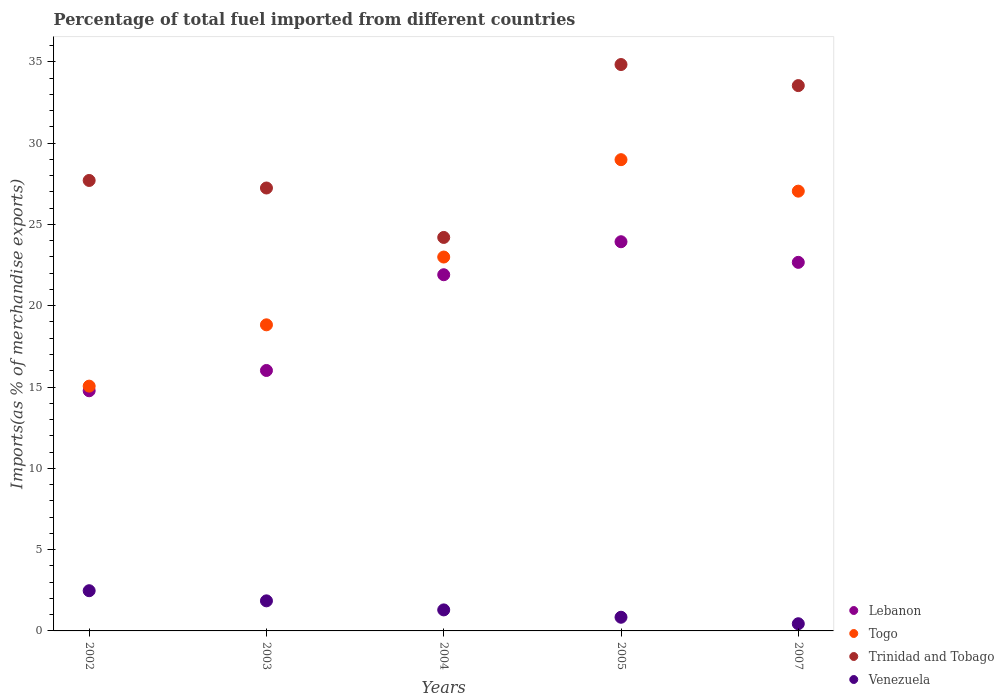Is the number of dotlines equal to the number of legend labels?
Offer a very short reply. Yes. What is the percentage of imports to different countries in Trinidad and Tobago in 2002?
Ensure brevity in your answer.  27.7. Across all years, what is the maximum percentage of imports to different countries in Togo?
Keep it short and to the point. 28.98. Across all years, what is the minimum percentage of imports to different countries in Togo?
Your answer should be very brief. 15.05. What is the total percentage of imports to different countries in Lebanon in the graph?
Offer a terse response. 99.29. What is the difference between the percentage of imports to different countries in Lebanon in 2002 and that in 2005?
Offer a very short reply. -9.16. What is the difference between the percentage of imports to different countries in Lebanon in 2005 and the percentage of imports to different countries in Venezuela in 2007?
Give a very brief answer. 23.49. What is the average percentage of imports to different countries in Lebanon per year?
Your answer should be very brief. 19.86. In the year 2005, what is the difference between the percentage of imports to different countries in Venezuela and percentage of imports to different countries in Togo?
Offer a very short reply. -28.14. What is the ratio of the percentage of imports to different countries in Venezuela in 2004 to that in 2005?
Keep it short and to the point. 1.54. Is the difference between the percentage of imports to different countries in Venezuela in 2002 and 2004 greater than the difference between the percentage of imports to different countries in Togo in 2002 and 2004?
Keep it short and to the point. Yes. What is the difference between the highest and the second highest percentage of imports to different countries in Venezuela?
Your response must be concise. 0.62. What is the difference between the highest and the lowest percentage of imports to different countries in Lebanon?
Provide a succinct answer. 9.16. Is it the case that in every year, the sum of the percentage of imports to different countries in Lebanon and percentage of imports to different countries in Togo  is greater than the sum of percentage of imports to different countries in Venezuela and percentage of imports to different countries in Trinidad and Tobago?
Provide a succinct answer. No. Is the percentage of imports to different countries in Lebanon strictly less than the percentage of imports to different countries in Trinidad and Tobago over the years?
Offer a terse response. Yes. How many dotlines are there?
Offer a very short reply. 4. How many years are there in the graph?
Your answer should be very brief. 5. Does the graph contain grids?
Offer a terse response. No. How many legend labels are there?
Ensure brevity in your answer.  4. What is the title of the graph?
Make the answer very short. Percentage of total fuel imported from different countries. Does "Israel" appear as one of the legend labels in the graph?
Make the answer very short. No. What is the label or title of the X-axis?
Keep it short and to the point. Years. What is the label or title of the Y-axis?
Your answer should be very brief. Imports(as % of merchandise exports). What is the Imports(as % of merchandise exports) of Lebanon in 2002?
Offer a very short reply. 14.77. What is the Imports(as % of merchandise exports) in Togo in 2002?
Provide a succinct answer. 15.05. What is the Imports(as % of merchandise exports) in Trinidad and Tobago in 2002?
Your response must be concise. 27.7. What is the Imports(as % of merchandise exports) of Venezuela in 2002?
Give a very brief answer. 2.47. What is the Imports(as % of merchandise exports) of Lebanon in 2003?
Offer a very short reply. 16.02. What is the Imports(as % of merchandise exports) of Togo in 2003?
Offer a terse response. 18.82. What is the Imports(as % of merchandise exports) in Trinidad and Tobago in 2003?
Offer a very short reply. 27.24. What is the Imports(as % of merchandise exports) in Venezuela in 2003?
Provide a succinct answer. 1.85. What is the Imports(as % of merchandise exports) in Lebanon in 2004?
Offer a terse response. 21.9. What is the Imports(as % of merchandise exports) of Togo in 2004?
Provide a short and direct response. 22.99. What is the Imports(as % of merchandise exports) in Trinidad and Tobago in 2004?
Give a very brief answer. 24.2. What is the Imports(as % of merchandise exports) of Venezuela in 2004?
Give a very brief answer. 1.29. What is the Imports(as % of merchandise exports) of Lebanon in 2005?
Provide a short and direct response. 23.93. What is the Imports(as % of merchandise exports) in Togo in 2005?
Your answer should be very brief. 28.98. What is the Imports(as % of merchandise exports) in Trinidad and Tobago in 2005?
Offer a very short reply. 34.83. What is the Imports(as % of merchandise exports) in Venezuela in 2005?
Your answer should be very brief. 0.84. What is the Imports(as % of merchandise exports) of Lebanon in 2007?
Provide a short and direct response. 22.67. What is the Imports(as % of merchandise exports) in Togo in 2007?
Your response must be concise. 27.04. What is the Imports(as % of merchandise exports) in Trinidad and Tobago in 2007?
Provide a succinct answer. 33.54. What is the Imports(as % of merchandise exports) in Venezuela in 2007?
Keep it short and to the point. 0.44. Across all years, what is the maximum Imports(as % of merchandise exports) in Lebanon?
Make the answer very short. 23.93. Across all years, what is the maximum Imports(as % of merchandise exports) of Togo?
Offer a very short reply. 28.98. Across all years, what is the maximum Imports(as % of merchandise exports) of Trinidad and Tobago?
Ensure brevity in your answer.  34.83. Across all years, what is the maximum Imports(as % of merchandise exports) of Venezuela?
Your response must be concise. 2.47. Across all years, what is the minimum Imports(as % of merchandise exports) in Lebanon?
Your response must be concise. 14.77. Across all years, what is the minimum Imports(as % of merchandise exports) in Togo?
Offer a very short reply. 15.05. Across all years, what is the minimum Imports(as % of merchandise exports) of Trinidad and Tobago?
Your answer should be very brief. 24.2. Across all years, what is the minimum Imports(as % of merchandise exports) of Venezuela?
Provide a succinct answer. 0.44. What is the total Imports(as % of merchandise exports) of Lebanon in the graph?
Keep it short and to the point. 99.29. What is the total Imports(as % of merchandise exports) of Togo in the graph?
Give a very brief answer. 112.9. What is the total Imports(as % of merchandise exports) of Trinidad and Tobago in the graph?
Offer a very short reply. 147.51. What is the total Imports(as % of merchandise exports) in Venezuela in the graph?
Offer a very short reply. 6.9. What is the difference between the Imports(as % of merchandise exports) in Lebanon in 2002 and that in 2003?
Provide a succinct answer. -1.25. What is the difference between the Imports(as % of merchandise exports) in Togo in 2002 and that in 2003?
Keep it short and to the point. -3.77. What is the difference between the Imports(as % of merchandise exports) in Trinidad and Tobago in 2002 and that in 2003?
Make the answer very short. 0.46. What is the difference between the Imports(as % of merchandise exports) in Venezuela in 2002 and that in 2003?
Make the answer very short. 0.62. What is the difference between the Imports(as % of merchandise exports) of Lebanon in 2002 and that in 2004?
Your response must be concise. -7.14. What is the difference between the Imports(as % of merchandise exports) in Togo in 2002 and that in 2004?
Your answer should be compact. -7.94. What is the difference between the Imports(as % of merchandise exports) of Trinidad and Tobago in 2002 and that in 2004?
Your answer should be compact. 3.5. What is the difference between the Imports(as % of merchandise exports) of Venezuela in 2002 and that in 2004?
Your answer should be compact. 1.18. What is the difference between the Imports(as % of merchandise exports) in Lebanon in 2002 and that in 2005?
Your answer should be compact. -9.16. What is the difference between the Imports(as % of merchandise exports) of Togo in 2002 and that in 2005?
Provide a succinct answer. -13.93. What is the difference between the Imports(as % of merchandise exports) of Trinidad and Tobago in 2002 and that in 2005?
Ensure brevity in your answer.  -7.13. What is the difference between the Imports(as % of merchandise exports) in Venezuela in 2002 and that in 2005?
Make the answer very short. 1.63. What is the difference between the Imports(as % of merchandise exports) in Lebanon in 2002 and that in 2007?
Make the answer very short. -7.9. What is the difference between the Imports(as % of merchandise exports) in Togo in 2002 and that in 2007?
Offer a very short reply. -11.99. What is the difference between the Imports(as % of merchandise exports) of Trinidad and Tobago in 2002 and that in 2007?
Keep it short and to the point. -5.83. What is the difference between the Imports(as % of merchandise exports) in Venezuela in 2002 and that in 2007?
Offer a very short reply. 2.03. What is the difference between the Imports(as % of merchandise exports) of Lebanon in 2003 and that in 2004?
Offer a very short reply. -5.89. What is the difference between the Imports(as % of merchandise exports) of Togo in 2003 and that in 2004?
Offer a very short reply. -4.17. What is the difference between the Imports(as % of merchandise exports) in Trinidad and Tobago in 2003 and that in 2004?
Make the answer very short. 3.04. What is the difference between the Imports(as % of merchandise exports) in Venezuela in 2003 and that in 2004?
Your answer should be compact. 0.56. What is the difference between the Imports(as % of merchandise exports) of Lebanon in 2003 and that in 2005?
Ensure brevity in your answer.  -7.92. What is the difference between the Imports(as % of merchandise exports) in Togo in 2003 and that in 2005?
Provide a short and direct response. -10.16. What is the difference between the Imports(as % of merchandise exports) of Trinidad and Tobago in 2003 and that in 2005?
Offer a terse response. -7.59. What is the difference between the Imports(as % of merchandise exports) in Venezuela in 2003 and that in 2005?
Give a very brief answer. 1.01. What is the difference between the Imports(as % of merchandise exports) in Lebanon in 2003 and that in 2007?
Make the answer very short. -6.65. What is the difference between the Imports(as % of merchandise exports) of Togo in 2003 and that in 2007?
Your answer should be compact. -8.22. What is the difference between the Imports(as % of merchandise exports) in Trinidad and Tobago in 2003 and that in 2007?
Ensure brevity in your answer.  -6.3. What is the difference between the Imports(as % of merchandise exports) of Venezuela in 2003 and that in 2007?
Your answer should be very brief. 1.41. What is the difference between the Imports(as % of merchandise exports) in Lebanon in 2004 and that in 2005?
Your answer should be compact. -2.03. What is the difference between the Imports(as % of merchandise exports) of Togo in 2004 and that in 2005?
Your answer should be compact. -5.99. What is the difference between the Imports(as % of merchandise exports) in Trinidad and Tobago in 2004 and that in 2005?
Offer a terse response. -10.63. What is the difference between the Imports(as % of merchandise exports) in Venezuela in 2004 and that in 2005?
Give a very brief answer. 0.45. What is the difference between the Imports(as % of merchandise exports) of Lebanon in 2004 and that in 2007?
Your response must be concise. -0.76. What is the difference between the Imports(as % of merchandise exports) in Togo in 2004 and that in 2007?
Give a very brief answer. -4.05. What is the difference between the Imports(as % of merchandise exports) in Trinidad and Tobago in 2004 and that in 2007?
Provide a succinct answer. -9.34. What is the difference between the Imports(as % of merchandise exports) in Venezuela in 2004 and that in 2007?
Your answer should be compact. 0.85. What is the difference between the Imports(as % of merchandise exports) in Lebanon in 2005 and that in 2007?
Offer a very short reply. 1.27. What is the difference between the Imports(as % of merchandise exports) in Togo in 2005 and that in 2007?
Give a very brief answer. 1.94. What is the difference between the Imports(as % of merchandise exports) of Trinidad and Tobago in 2005 and that in 2007?
Your answer should be compact. 1.3. What is the difference between the Imports(as % of merchandise exports) of Venezuela in 2005 and that in 2007?
Ensure brevity in your answer.  0.4. What is the difference between the Imports(as % of merchandise exports) in Lebanon in 2002 and the Imports(as % of merchandise exports) in Togo in 2003?
Provide a short and direct response. -4.06. What is the difference between the Imports(as % of merchandise exports) in Lebanon in 2002 and the Imports(as % of merchandise exports) in Trinidad and Tobago in 2003?
Offer a terse response. -12.47. What is the difference between the Imports(as % of merchandise exports) in Lebanon in 2002 and the Imports(as % of merchandise exports) in Venezuela in 2003?
Offer a terse response. 12.92. What is the difference between the Imports(as % of merchandise exports) of Togo in 2002 and the Imports(as % of merchandise exports) of Trinidad and Tobago in 2003?
Give a very brief answer. -12.18. What is the difference between the Imports(as % of merchandise exports) of Togo in 2002 and the Imports(as % of merchandise exports) of Venezuela in 2003?
Make the answer very short. 13.2. What is the difference between the Imports(as % of merchandise exports) of Trinidad and Tobago in 2002 and the Imports(as % of merchandise exports) of Venezuela in 2003?
Keep it short and to the point. 25.85. What is the difference between the Imports(as % of merchandise exports) of Lebanon in 2002 and the Imports(as % of merchandise exports) of Togo in 2004?
Give a very brief answer. -8.22. What is the difference between the Imports(as % of merchandise exports) in Lebanon in 2002 and the Imports(as % of merchandise exports) in Trinidad and Tobago in 2004?
Your response must be concise. -9.43. What is the difference between the Imports(as % of merchandise exports) of Lebanon in 2002 and the Imports(as % of merchandise exports) of Venezuela in 2004?
Offer a very short reply. 13.48. What is the difference between the Imports(as % of merchandise exports) in Togo in 2002 and the Imports(as % of merchandise exports) in Trinidad and Tobago in 2004?
Make the answer very short. -9.14. What is the difference between the Imports(as % of merchandise exports) of Togo in 2002 and the Imports(as % of merchandise exports) of Venezuela in 2004?
Your answer should be very brief. 13.76. What is the difference between the Imports(as % of merchandise exports) in Trinidad and Tobago in 2002 and the Imports(as % of merchandise exports) in Venezuela in 2004?
Ensure brevity in your answer.  26.41. What is the difference between the Imports(as % of merchandise exports) in Lebanon in 2002 and the Imports(as % of merchandise exports) in Togo in 2005?
Give a very brief answer. -14.21. What is the difference between the Imports(as % of merchandise exports) of Lebanon in 2002 and the Imports(as % of merchandise exports) of Trinidad and Tobago in 2005?
Offer a very short reply. -20.06. What is the difference between the Imports(as % of merchandise exports) of Lebanon in 2002 and the Imports(as % of merchandise exports) of Venezuela in 2005?
Provide a short and direct response. 13.93. What is the difference between the Imports(as % of merchandise exports) in Togo in 2002 and the Imports(as % of merchandise exports) in Trinidad and Tobago in 2005?
Your answer should be compact. -19.78. What is the difference between the Imports(as % of merchandise exports) in Togo in 2002 and the Imports(as % of merchandise exports) in Venezuela in 2005?
Your response must be concise. 14.21. What is the difference between the Imports(as % of merchandise exports) in Trinidad and Tobago in 2002 and the Imports(as % of merchandise exports) in Venezuela in 2005?
Your answer should be very brief. 26.86. What is the difference between the Imports(as % of merchandise exports) in Lebanon in 2002 and the Imports(as % of merchandise exports) in Togo in 2007?
Offer a terse response. -12.28. What is the difference between the Imports(as % of merchandise exports) in Lebanon in 2002 and the Imports(as % of merchandise exports) in Trinidad and Tobago in 2007?
Make the answer very short. -18.77. What is the difference between the Imports(as % of merchandise exports) of Lebanon in 2002 and the Imports(as % of merchandise exports) of Venezuela in 2007?
Offer a terse response. 14.33. What is the difference between the Imports(as % of merchandise exports) of Togo in 2002 and the Imports(as % of merchandise exports) of Trinidad and Tobago in 2007?
Offer a terse response. -18.48. What is the difference between the Imports(as % of merchandise exports) of Togo in 2002 and the Imports(as % of merchandise exports) of Venezuela in 2007?
Your response must be concise. 14.61. What is the difference between the Imports(as % of merchandise exports) of Trinidad and Tobago in 2002 and the Imports(as % of merchandise exports) of Venezuela in 2007?
Offer a very short reply. 27.26. What is the difference between the Imports(as % of merchandise exports) of Lebanon in 2003 and the Imports(as % of merchandise exports) of Togo in 2004?
Provide a succinct answer. -6.98. What is the difference between the Imports(as % of merchandise exports) of Lebanon in 2003 and the Imports(as % of merchandise exports) of Trinidad and Tobago in 2004?
Provide a short and direct response. -8.18. What is the difference between the Imports(as % of merchandise exports) of Lebanon in 2003 and the Imports(as % of merchandise exports) of Venezuela in 2004?
Make the answer very short. 14.72. What is the difference between the Imports(as % of merchandise exports) in Togo in 2003 and the Imports(as % of merchandise exports) in Trinidad and Tobago in 2004?
Offer a very short reply. -5.37. What is the difference between the Imports(as % of merchandise exports) of Togo in 2003 and the Imports(as % of merchandise exports) of Venezuela in 2004?
Keep it short and to the point. 17.53. What is the difference between the Imports(as % of merchandise exports) of Trinidad and Tobago in 2003 and the Imports(as % of merchandise exports) of Venezuela in 2004?
Give a very brief answer. 25.95. What is the difference between the Imports(as % of merchandise exports) in Lebanon in 2003 and the Imports(as % of merchandise exports) in Togo in 2005?
Your answer should be compact. -12.96. What is the difference between the Imports(as % of merchandise exports) of Lebanon in 2003 and the Imports(as % of merchandise exports) of Trinidad and Tobago in 2005?
Your response must be concise. -18.81. What is the difference between the Imports(as % of merchandise exports) of Lebanon in 2003 and the Imports(as % of merchandise exports) of Venezuela in 2005?
Offer a terse response. 15.18. What is the difference between the Imports(as % of merchandise exports) of Togo in 2003 and the Imports(as % of merchandise exports) of Trinidad and Tobago in 2005?
Offer a terse response. -16.01. What is the difference between the Imports(as % of merchandise exports) of Togo in 2003 and the Imports(as % of merchandise exports) of Venezuela in 2005?
Keep it short and to the point. 17.98. What is the difference between the Imports(as % of merchandise exports) of Trinidad and Tobago in 2003 and the Imports(as % of merchandise exports) of Venezuela in 2005?
Keep it short and to the point. 26.4. What is the difference between the Imports(as % of merchandise exports) in Lebanon in 2003 and the Imports(as % of merchandise exports) in Togo in 2007?
Ensure brevity in your answer.  -11.03. What is the difference between the Imports(as % of merchandise exports) of Lebanon in 2003 and the Imports(as % of merchandise exports) of Trinidad and Tobago in 2007?
Offer a terse response. -17.52. What is the difference between the Imports(as % of merchandise exports) of Lebanon in 2003 and the Imports(as % of merchandise exports) of Venezuela in 2007?
Make the answer very short. 15.57. What is the difference between the Imports(as % of merchandise exports) in Togo in 2003 and the Imports(as % of merchandise exports) in Trinidad and Tobago in 2007?
Offer a terse response. -14.71. What is the difference between the Imports(as % of merchandise exports) of Togo in 2003 and the Imports(as % of merchandise exports) of Venezuela in 2007?
Offer a very short reply. 18.38. What is the difference between the Imports(as % of merchandise exports) of Trinidad and Tobago in 2003 and the Imports(as % of merchandise exports) of Venezuela in 2007?
Offer a terse response. 26.8. What is the difference between the Imports(as % of merchandise exports) of Lebanon in 2004 and the Imports(as % of merchandise exports) of Togo in 2005?
Give a very brief answer. -7.08. What is the difference between the Imports(as % of merchandise exports) of Lebanon in 2004 and the Imports(as % of merchandise exports) of Trinidad and Tobago in 2005?
Make the answer very short. -12.93. What is the difference between the Imports(as % of merchandise exports) of Lebanon in 2004 and the Imports(as % of merchandise exports) of Venezuela in 2005?
Give a very brief answer. 21.06. What is the difference between the Imports(as % of merchandise exports) in Togo in 2004 and the Imports(as % of merchandise exports) in Trinidad and Tobago in 2005?
Give a very brief answer. -11.84. What is the difference between the Imports(as % of merchandise exports) in Togo in 2004 and the Imports(as % of merchandise exports) in Venezuela in 2005?
Provide a succinct answer. 22.15. What is the difference between the Imports(as % of merchandise exports) in Trinidad and Tobago in 2004 and the Imports(as % of merchandise exports) in Venezuela in 2005?
Your response must be concise. 23.36. What is the difference between the Imports(as % of merchandise exports) in Lebanon in 2004 and the Imports(as % of merchandise exports) in Togo in 2007?
Offer a terse response. -5.14. What is the difference between the Imports(as % of merchandise exports) of Lebanon in 2004 and the Imports(as % of merchandise exports) of Trinidad and Tobago in 2007?
Your answer should be compact. -11.63. What is the difference between the Imports(as % of merchandise exports) of Lebanon in 2004 and the Imports(as % of merchandise exports) of Venezuela in 2007?
Provide a short and direct response. 21.46. What is the difference between the Imports(as % of merchandise exports) of Togo in 2004 and the Imports(as % of merchandise exports) of Trinidad and Tobago in 2007?
Your answer should be compact. -10.54. What is the difference between the Imports(as % of merchandise exports) in Togo in 2004 and the Imports(as % of merchandise exports) in Venezuela in 2007?
Ensure brevity in your answer.  22.55. What is the difference between the Imports(as % of merchandise exports) in Trinidad and Tobago in 2004 and the Imports(as % of merchandise exports) in Venezuela in 2007?
Offer a terse response. 23.76. What is the difference between the Imports(as % of merchandise exports) in Lebanon in 2005 and the Imports(as % of merchandise exports) in Togo in 2007?
Offer a very short reply. -3.11. What is the difference between the Imports(as % of merchandise exports) in Lebanon in 2005 and the Imports(as % of merchandise exports) in Trinidad and Tobago in 2007?
Your answer should be compact. -9.6. What is the difference between the Imports(as % of merchandise exports) in Lebanon in 2005 and the Imports(as % of merchandise exports) in Venezuela in 2007?
Your response must be concise. 23.49. What is the difference between the Imports(as % of merchandise exports) in Togo in 2005 and the Imports(as % of merchandise exports) in Trinidad and Tobago in 2007?
Make the answer very short. -4.56. What is the difference between the Imports(as % of merchandise exports) in Togo in 2005 and the Imports(as % of merchandise exports) in Venezuela in 2007?
Provide a short and direct response. 28.54. What is the difference between the Imports(as % of merchandise exports) in Trinidad and Tobago in 2005 and the Imports(as % of merchandise exports) in Venezuela in 2007?
Keep it short and to the point. 34.39. What is the average Imports(as % of merchandise exports) in Lebanon per year?
Your answer should be compact. 19.86. What is the average Imports(as % of merchandise exports) of Togo per year?
Your response must be concise. 22.58. What is the average Imports(as % of merchandise exports) in Trinidad and Tobago per year?
Make the answer very short. 29.5. What is the average Imports(as % of merchandise exports) of Venezuela per year?
Your response must be concise. 1.38. In the year 2002, what is the difference between the Imports(as % of merchandise exports) in Lebanon and Imports(as % of merchandise exports) in Togo?
Your answer should be very brief. -0.28. In the year 2002, what is the difference between the Imports(as % of merchandise exports) of Lebanon and Imports(as % of merchandise exports) of Trinidad and Tobago?
Provide a short and direct response. -12.93. In the year 2002, what is the difference between the Imports(as % of merchandise exports) of Lebanon and Imports(as % of merchandise exports) of Venezuela?
Give a very brief answer. 12.3. In the year 2002, what is the difference between the Imports(as % of merchandise exports) of Togo and Imports(as % of merchandise exports) of Trinidad and Tobago?
Offer a very short reply. -12.65. In the year 2002, what is the difference between the Imports(as % of merchandise exports) of Togo and Imports(as % of merchandise exports) of Venezuela?
Offer a very short reply. 12.58. In the year 2002, what is the difference between the Imports(as % of merchandise exports) of Trinidad and Tobago and Imports(as % of merchandise exports) of Venezuela?
Your response must be concise. 25.23. In the year 2003, what is the difference between the Imports(as % of merchandise exports) of Lebanon and Imports(as % of merchandise exports) of Togo?
Your answer should be very brief. -2.81. In the year 2003, what is the difference between the Imports(as % of merchandise exports) of Lebanon and Imports(as % of merchandise exports) of Trinidad and Tobago?
Keep it short and to the point. -11.22. In the year 2003, what is the difference between the Imports(as % of merchandise exports) of Lebanon and Imports(as % of merchandise exports) of Venezuela?
Your answer should be very brief. 14.17. In the year 2003, what is the difference between the Imports(as % of merchandise exports) of Togo and Imports(as % of merchandise exports) of Trinidad and Tobago?
Offer a terse response. -8.41. In the year 2003, what is the difference between the Imports(as % of merchandise exports) of Togo and Imports(as % of merchandise exports) of Venezuela?
Ensure brevity in your answer.  16.97. In the year 2003, what is the difference between the Imports(as % of merchandise exports) in Trinidad and Tobago and Imports(as % of merchandise exports) in Venezuela?
Make the answer very short. 25.39. In the year 2004, what is the difference between the Imports(as % of merchandise exports) in Lebanon and Imports(as % of merchandise exports) in Togo?
Give a very brief answer. -1.09. In the year 2004, what is the difference between the Imports(as % of merchandise exports) in Lebanon and Imports(as % of merchandise exports) in Trinidad and Tobago?
Offer a very short reply. -2.29. In the year 2004, what is the difference between the Imports(as % of merchandise exports) of Lebanon and Imports(as % of merchandise exports) of Venezuela?
Your answer should be very brief. 20.61. In the year 2004, what is the difference between the Imports(as % of merchandise exports) in Togo and Imports(as % of merchandise exports) in Trinidad and Tobago?
Provide a short and direct response. -1.21. In the year 2004, what is the difference between the Imports(as % of merchandise exports) in Togo and Imports(as % of merchandise exports) in Venezuela?
Keep it short and to the point. 21.7. In the year 2004, what is the difference between the Imports(as % of merchandise exports) of Trinidad and Tobago and Imports(as % of merchandise exports) of Venezuela?
Keep it short and to the point. 22.91. In the year 2005, what is the difference between the Imports(as % of merchandise exports) in Lebanon and Imports(as % of merchandise exports) in Togo?
Make the answer very short. -5.05. In the year 2005, what is the difference between the Imports(as % of merchandise exports) in Lebanon and Imports(as % of merchandise exports) in Trinidad and Tobago?
Your answer should be very brief. -10.9. In the year 2005, what is the difference between the Imports(as % of merchandise exports) in Lebanon and Imports(as % of merchandise exports) in Venezuela?
Your answer should be compact. 23.09. In the year 2005, what is the difference between the Imports(as % of merchandise exports) of Togo and Imports(as % of merchandise exports) of Trinidad and Tobago?
Keep it short and to the point. -5.85. In the year 2005, what is the difference between the Imports(as % of merchandise exports) of Togo and Imports(as % of merchandise exports) of Venezuela?
Provide a succinct answer. 28.14. In the year 2005, what is the difference between the Imports(as % of merchandise exports) of Trinidad and Tobago and Imports(as % of merchandise exports) of Venezuela?
Offer a very short reply. 33.99. In the year 2007, what is the difference between the Imports(as % of merchandise exports) in Lebanon and Imports(as % of merchandise exports) in Togo?
Give a very brief answer. -4.38. In the year 2007, what is the difference between the Imports(as % of merchandise exports) of Lebanon and Imports(as % of merchandise exports) of Trinidad and Tobago?
Offer a terse response. -10.87. In the year 2007, what is the difference between the Imports(as % of merchandise exports) in Lebanon and Imports(as % of merchandise exports) in Venezuela?
Provide a succinct answer. 22.22. In the year 2007, what is the difference between the Imports(as % of merchandise exports) of Togo and Imports(as % of merchandise exports) of Trinidad and Tobago?
Keep it short and to the point. -6.49. In the year 2007, what is the difference between the Imports(as % of merchandise exports) in Togo and Imports(as % of merchandise exports) in Venezuela?
Keep it short and to the point. 26.6. In the year 2007, what is the difference between the Imports(as % of merchandise exports) in Trinidad and Tobago and Imports(as % of merchandise exports) in Venezuela?
Your answer should be very brief. 33.09. What is the ratio of the Imports(as % of merchandise exports) in Lebanon in 2002 to that in 2003?
Your response must be concise. 0.92. What is the ratio of the Imports(as % of merchandise exports) of Togo in 2002 to that in 2003?
Offer a terse response. 0.8. What is the ratio of the Imports(as % of merchandise exports) in Trinidad and Tobago in 2002 to that in 2003?
Offer a very short reply. 1.02. What is the ratio of the Imports(as % of merchandise exports) of Venezuela in 2002 to that in 2003?
Your answer should be compact. 1.34. What is the ratio of the Imports(as % of merchandise exports) in Lebanon in 2002 to that in 2004?
Ensure brevity in your answer.  0.67. What is the ratio of the Imports(as % of merchandise exports) in Togo in 2002 to that in 2004?
Your answer should be compact. 0.65. What is the ratio of the Imports(as % of merchandise exports) of Trinidad and Tobago in 2002 to that in 2004?
Your answer should be compact. 1.14. What is the ratio of the Imports(as % of merchandise exports) of Venezuela in 2002 to that in 2004?
Provide a succinct answer. 1.91. What is the ratio of the Imports(as % of merchandise exports) of Lebanon in 2002 to that in 2005?
Provide a short and direct response. 0.62. What is the ratio of the Imports(as % of merchandise exports) in Togo in 2002 to that in 2005?
Provide a succinct answer. 0.52. What is the ratio of the Imports(as % of merchandise exports) in Trinidad and Tobago in 2002 to that in 2005?
Your answer should be very brief. 0.8. What is the ratio of the Imports(as % of merchandise exports) in Venezuela in 2002 to that in 2005?
Keep it short and to the point. 2.94. What is the ratio of the Imports(as % of merchandise exports) in Lebanon in 2002 to that in 2007?
Give a very brief answer. 0.65. What is the ratio of the Imports(as % of merchandise exports) in Togo in 2002 to that in 2007?
Give a very brief answer. 0.56. What is the ratio of the Imports(as % of merchandise exports) of Trinidad and Tobago in 2002 to that in 2007?
Keep it short and to the point. 0.83. What is the ratio of the Imports(as % of merchandise exports) in Venezuela in 2002 to that in 2007?
Provide a short and direct response. 5.59. What is the ratio of the Imports(as % of merchandise exports) of Lebanon in 2003 to that in 2004?
Give a very brief answer. 0.73. What is the ratio of the Imports(as % of merchandise exports) of Togo in 2003 to that in 2004?
Offer a terse response. 0.82. What is the ratio of the Imports(as % of merchandise exports) in Trinidad and Tobago in 2003 to that in 2004?
Ensure brevity in your answer.  1.13. What is the ratio of the Imports(as % of merchandise exports) in Venezuela in 2003 to that in 2004?
Your answer should be very brief. 1.43. What is the ratio of the Imports(as % of merchandise exports) in Lebanon in 2003 to that in 2005?
Your response must be concise. 0.67. What is the ratio of the Imports(as % of merchandise exports) of Togo in 2003 to that in 2005?
Give a very brief answer. 0.65. What is the ratio of the Imports(as % of merchandise exports) of Trinidad and Tobago in 2003 to that in 2005?
Your answer should be compact. 0.78. What is the ratio of the Imports(as % of merchandise exports) of Venezuela in 2003 to that in 2005?
Offer a very short reply. 2.2. What is the ratio of the Imports(as % of merchandise exports) in Lebanon in 2003 to that in 2007?
Offer a very short reply. 0.71. What is the ratio of the Imports(as % of merchandise exports) of Togo in 2003 to that in 2007?
Provide a succinct answer. 0.7. What is the ratio of the Imports(as % of merchandise exports) of Trinidad and Tobago in 2003 to that in 2007?
Make the answer very short. 0.81. What is the ratio of the Imports(as % of merchandise exports) in Venezuela in 2003 to that in 2007?
Your answer should be very brief. 4.18. What is the ratio of the Imports(as % of merchandise exports) in Lebanon in 2004 to that in 2005?
Provide a short and direct response. 0.92. What is the ratio of the Imports(as % of merchandise exports) in Togo in 2004 to that in 2005?
Make the answer very short. 0.79. What is the ratio of the Imports(as % of merchandise exports) of Trinidad and Tobago in 2004 to that in 2005?
Ensure brevity in your answer.  0.69. What is the ratio of the Imports(as % of merchandise exports) in Venezuela in 2004 to that in 2005?
Make the answer very short. 1.54. What is the ratio of the Imports(as % of merchandise exports) in Lebanon in 2004 to that in 2007?
Offer a terse response. 0.97. What is the ratio of the Imports(as % of merchandise exports) of Togo in 2004 to that in 2007?
Give a very brief answer. 0.85. What is the ratio of the Imports(as % of merchandise exports) of Trinidad and Tobago in 2004 to that in 2007?
Offer a terse response. 0.72. What is the ratio of the Imports(as % of merchandise exports) in Venezuela in 2004 to that in 2007?
Ensure brevity in your answer.  2.92. What is the ratio of the Imports(as % of merchandise exports) of Lebanon in 2005 to that in 2007?
Give a very brief answer. 1.06. What is the ratio of the Imports(as % of merchandise exports) in Togo in 2005 to that in 2007?
Provide a short and direct response. 1.07. What is the ratio of the Imports(as % of merchandise exports) of Trinidad and Tobago in 2005 to that in 2007?
Offer a terse response. 1.04. What is the ratio of the Imports(as % of merchandise exports) of Venezuela in 2005 to that in 2007?
Your response must be concise. 1.9. What is the difference between the highest and the second highest Imports(as % of merchandise exports) in Lebanon?
Offer a very short reply. 1.27. What is the difference between the highest and the second highest Imports(as % of merchandise exports) of Togo?
Your answer should be compact. 1.94. What is the difference between the highest and the second highest Imports(as % of merchandise exports) of Trinidad and Tobago?
Offer a very short reply. 1.3. What is the difference between the highest and the second highest Imports(as % of merchandise exports) in Venezuela?
Offer a terse response. 0.62. What is the difference between the highest and the lowest Imports(as % of merchandise exports) of Lebanon?
Provide a short and direct response. 9.16. What is the difference between the highest and the lowest Imports(as % of merchandise exports) in Togo?
Make the answer very short. 13.93. What is the difference between the highest and the lowest Imports(as % of merchandise exports) of Trinidad and Tobago?
Your answer should be very brief. 10.63. What is the difference between the highest and the lowest Imports(as % of merchandise exports) in Venezuela?
Provide a short and direct response. 2.03. 